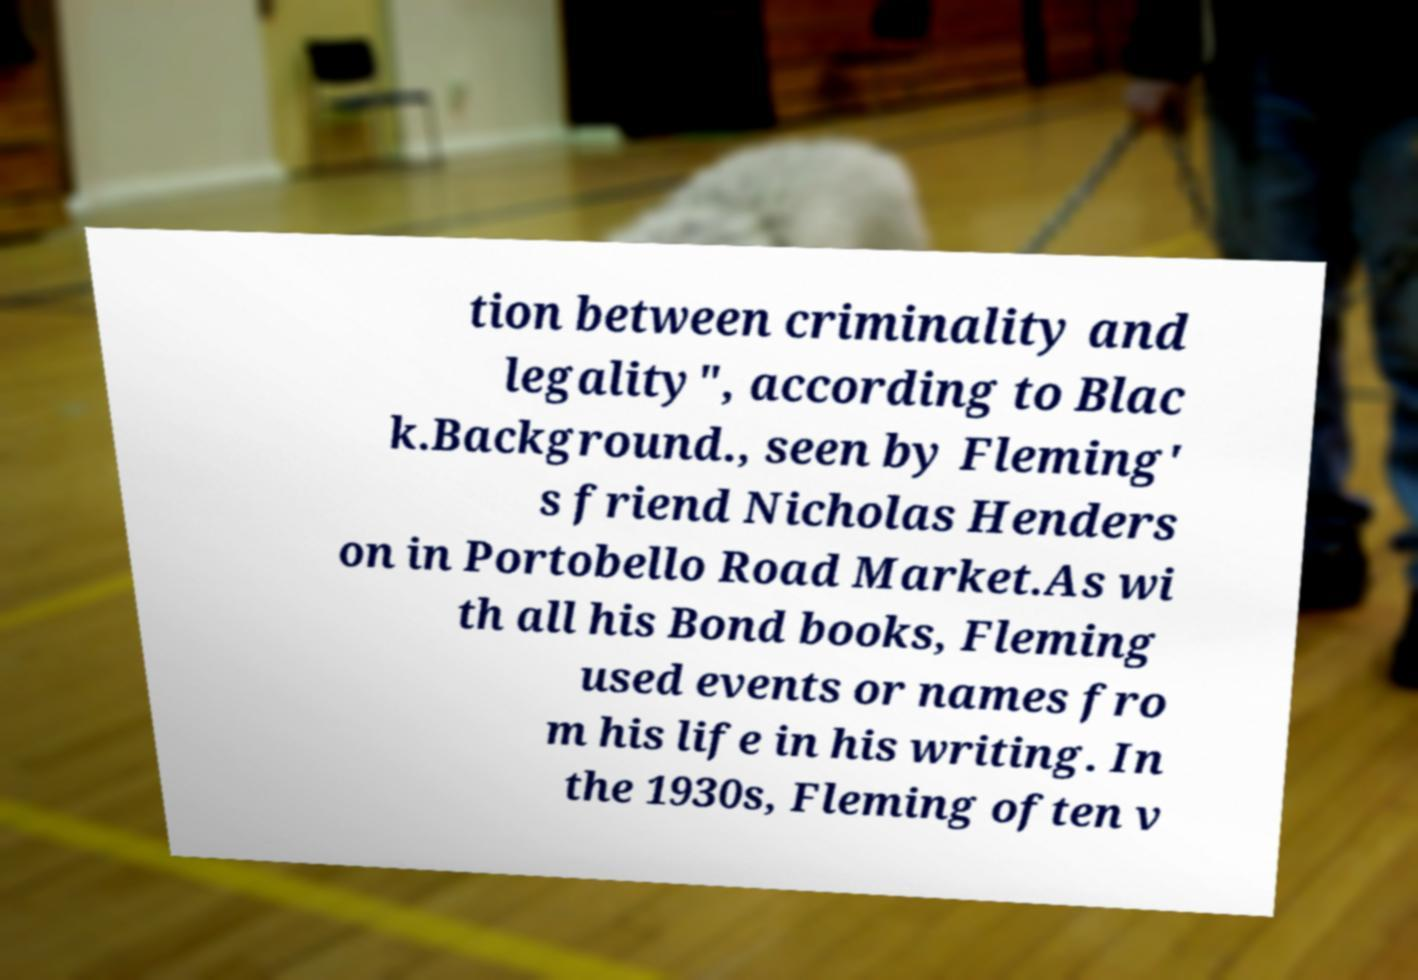Could you assist in decoding the text presented in this image and type it out clearly? tion between criminality and legality", according to Blac k.Background., seen by Fleming' s friend Nicholas Henders on in Portobello Road Market.As wi th all his Bond books, Fleming used events or names fro m his life in his writing. In the 1930s, Fleming often v 